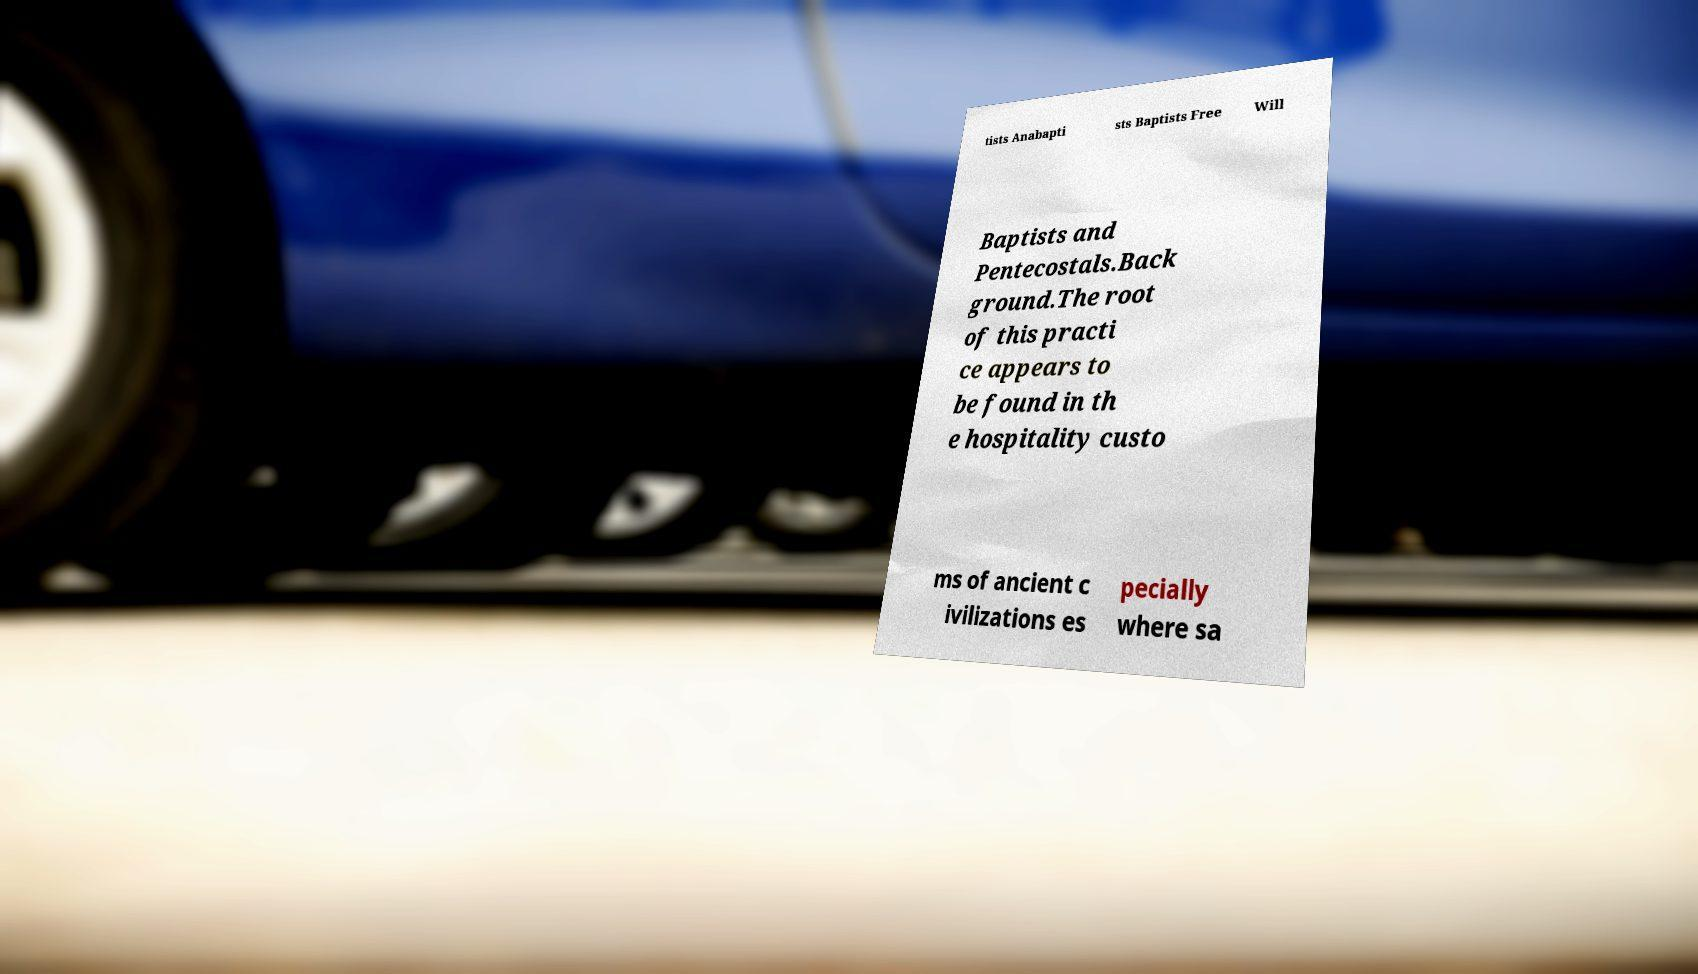I need the written content from this picture converted into text. Can you do that? tists Anabapti sts Baptists Free Will Baptists and Pentecostals.Back ground.The root of this practi ce appears to be found in th e hospitality custo ms of ancient c ivilizations es pecially where sa 